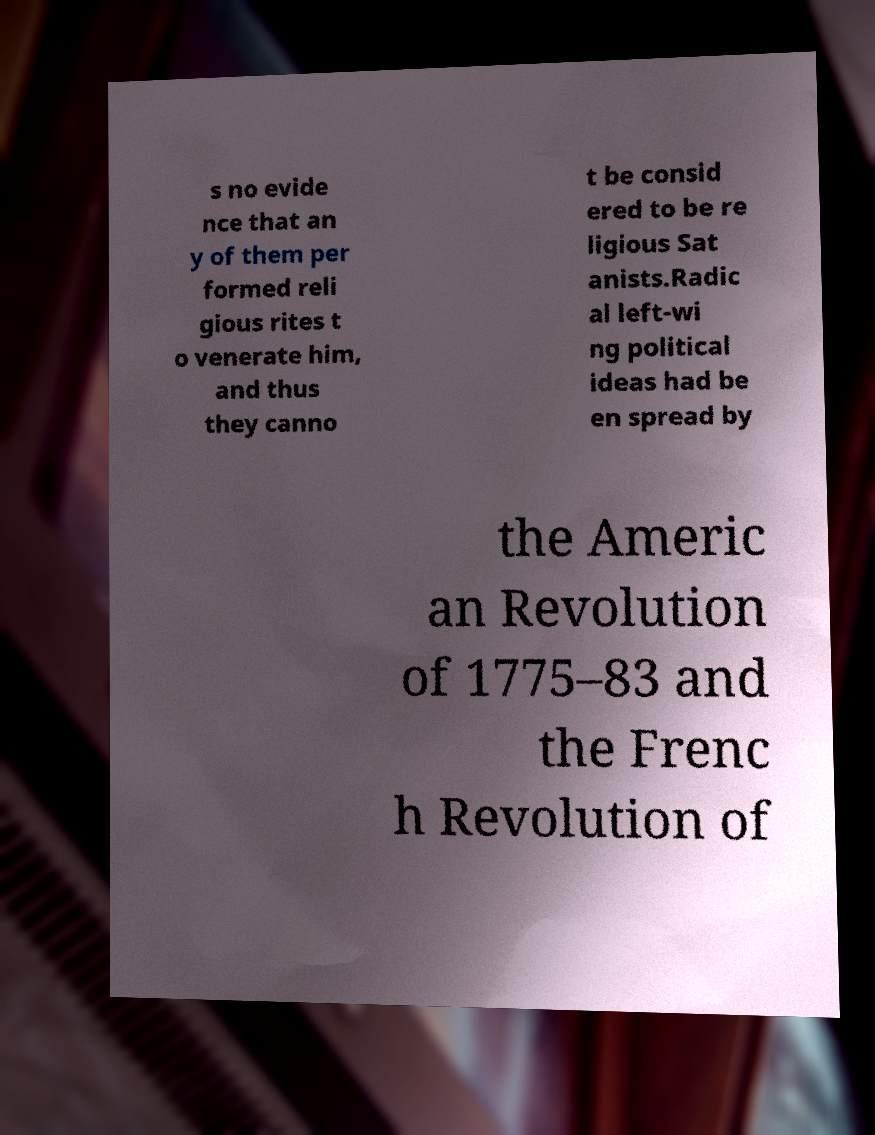I need the written content from this picture converted into text. Can you do that? s no evide nce that an y of them per formed reli gious rites t o venerate him, and thus they canno t be consid ered to be re ligious Sat anists.Radic al left-wi ng political ideas had be en spread by the Americ an Revolution of 1775–83 and the Frenc h Revolution of 